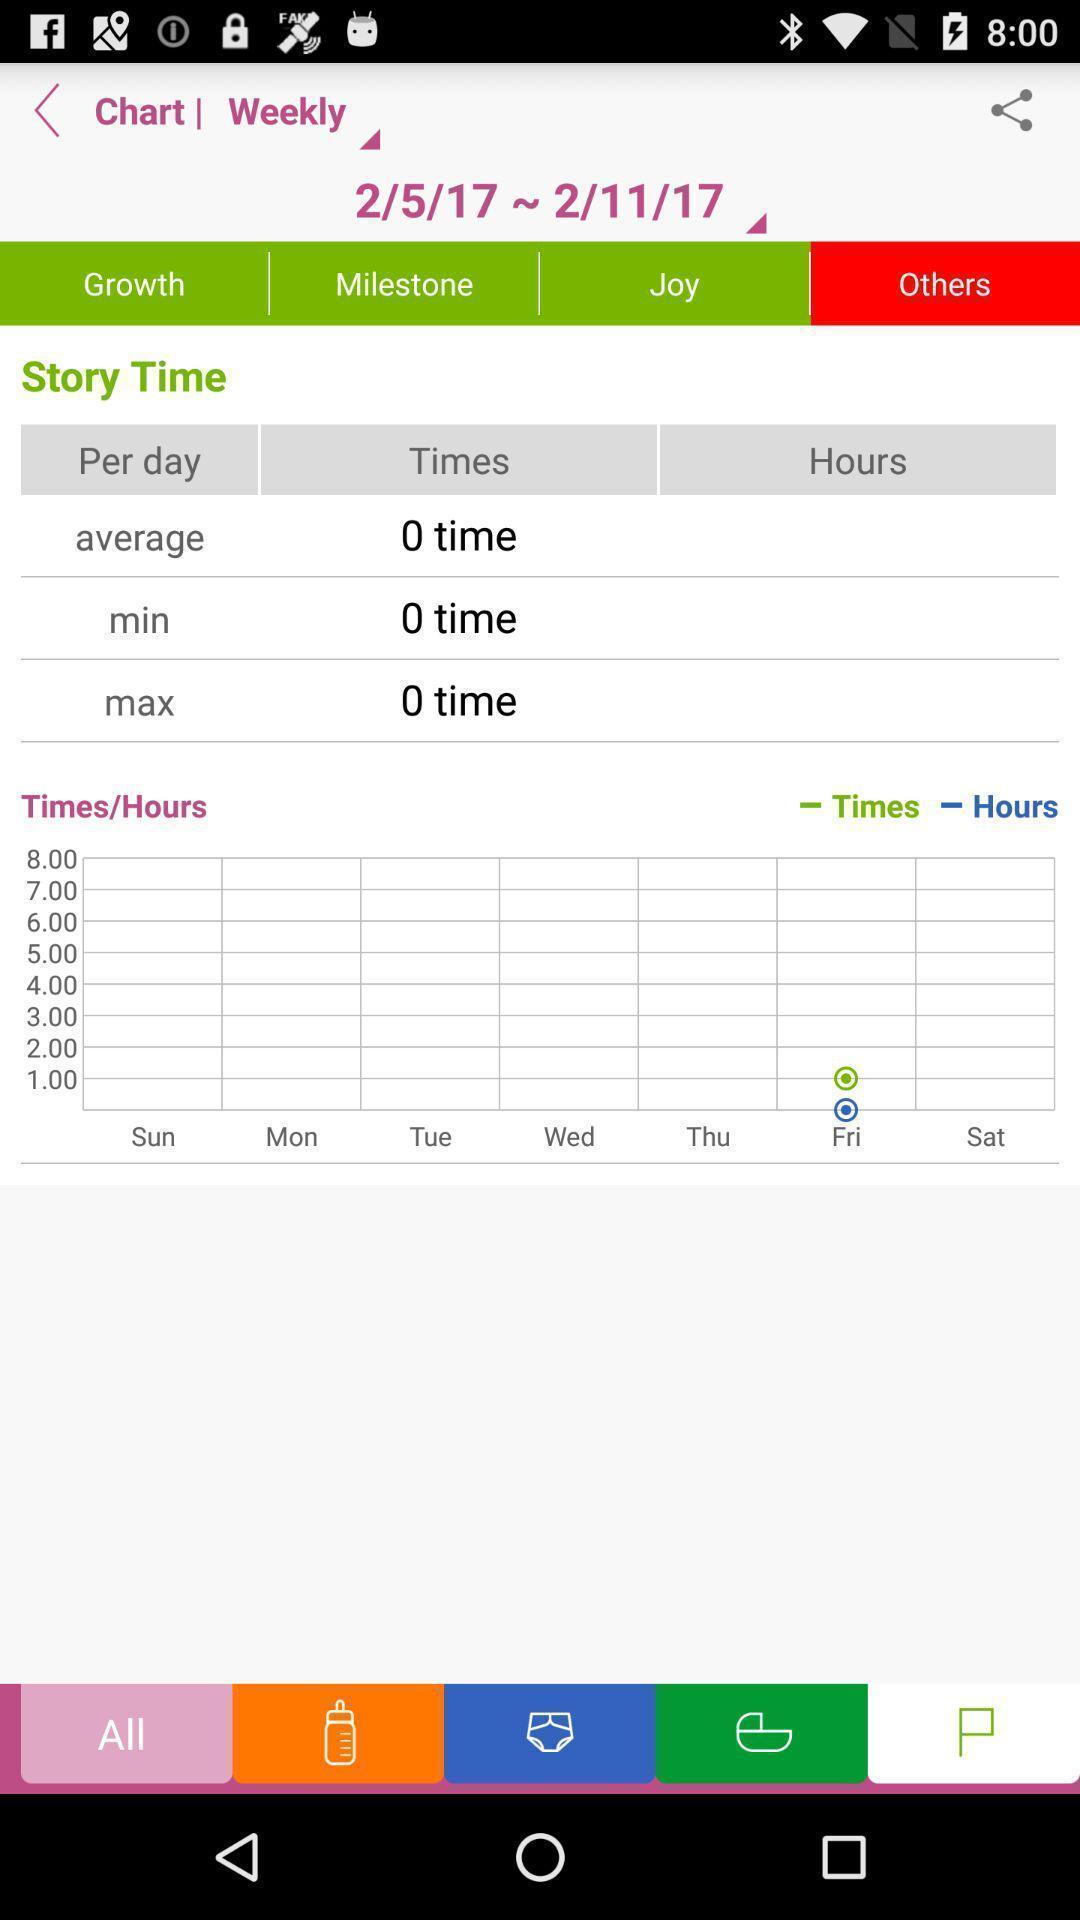What is the overall content of this screenshot? Screen displaying multiple time options and a share icon. 